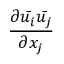<formula> <loc_0><loc_0><loc_500><loc_500>\frac { \partial { \bar { u _ { i } } } { \bar { u _ { j } } } } { \partial x _ { j } }</formula> 